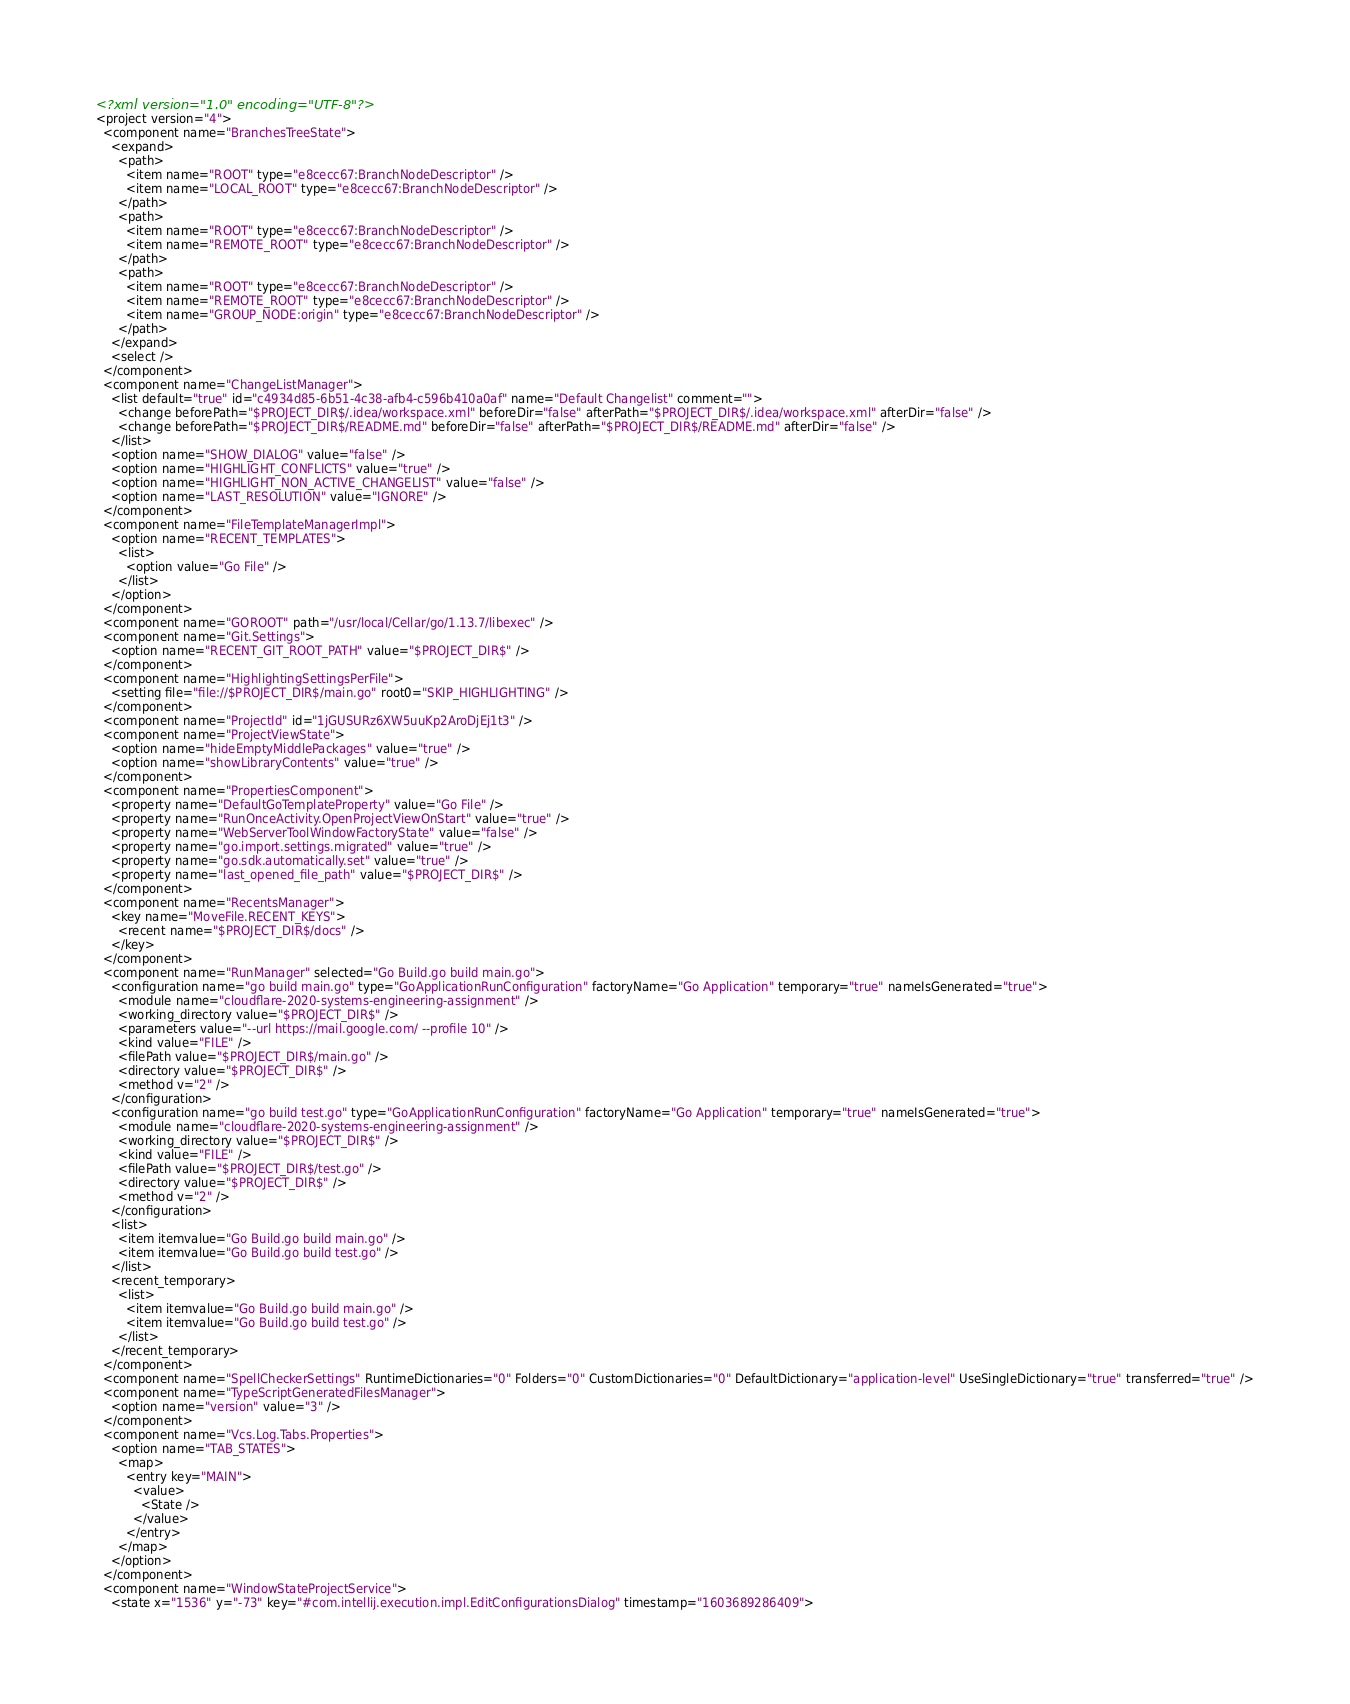Convert code to text. <code><loc_0><loc_0><loc_500><loc_500><_XML_><?xml version="1.0" encoding="UTF-8"?>
<project version="4">
  <component name="BranchesTreeState">
    <expand>
      <path>
        <item name="ROOT" type="e8cecc67:BranchNodeDescriptor" />
        <item name="LOCAL_ROOT" type="e8cecc67:BranchNodeDescriptor" />
      </path>
      <path>
        <item name="ROOT" type="e8cecc67:BranchNodeDescriptor" />
        <item name="REMOTE_ROOT" type="e8cecc67:BranchNodeDescriptor" />
      </path>
      <path>
        <item name="ROOT" type="e8cecc67:BranchNodeDescriptor" />
        <item name="REMOTE_ROOT" type="e8cecc67:BranchNodeDescriptor" />
        <item name="GROUP_NODE:origin" type="e8cecc67:BranchNodeDescriptor" />
      </path>
    </expand>
    <select />
  </component>
  <component name="ChangeListManager">
    <list default="true" id="c4934d85-6b51-4c38-afb4-c596b410a0af" name="Default Changelist" comment="">
      <change beforePath="$PROJECT_DIR$/.idea/workspace.xml" beforeDir="false" afterPath="$PROJECT_DIR$/.idea/workspace.xml" afterDir="false" />
      <change beforePath="$PROJECT_DIR$/README.md" beforeDir="false" afterPath="$PROJECT_DIR$/README.md" afterDir="false" />
    </list>
    <option name="SHOW_DIALOG" value="false" />
    <option name="HIGHLIGHT_CONFLICTS" value="true" />
    <option name="HIGHLIGHT_NON_ACTIVE_CHANGELIST" value="false" />
    <option name="LAST_RESOLUTION" value="IGNORE" />
  </component>
  <component name="FileTemplateManagerImpl">
    <option name="RECENT_TEMPLATES">
      <list>
        <option value="Go File" />
      </list>
    </option>
  </component>
  <component name="GOROOT" path="/usr/local/Cellar/go/1.13.7/libexec" />
  <component name="Git.Settings">
    <option name="RECENT_GIT_ROOT_PATH" value="$PROJECT_DIR$" />
  </component>
  <component name="HighlightingSettingsPerFile">
    <setting file="file://$PROJECT_DIR$/main.go" root0="SKIP_HIGHLIGHTING" />
  </component>
  <component name="ProjectId" id="1jGUSURz6XW5uuKp2AroDjEj1t3" />
  <component name="ProjectViewState">
    <option name="hideEmptyMiddlePackages" value="true" />
    <option name="showLibraryContents" value="true" />
  </component>
  <component name="PropertiesComponent">
    <property name="DefaultGoTemplateProperty" value="Go File" />
    <property name="RunOnceActivity.OpenProjectViewOnStart" value="true" />
    <property name="WebServerToolWindowFactoryState" value="false" />
    <property name="go.import.settings.migrated" value="true" />
    <property name="go.sdk.automatically.set" value="true" />
    <property name="last_opened_file_path" value="$PROJECT_DIR$" />
  </component>
  <component name="RecentsManager">
    <key name="MoveFile.RECENT_KEYS">
      <recent name="$PROJECT_DIR$/docs" />
    </key>
  </component>
  <component name="RunManager" selected="Go Build.go build main.go">
    <configuration name="go build main.go" type="GoApplicationRunConfiguration" factoryName="Go Application" temporary="true" nameIsGenerated="true">
      <module name="cloudflare-2020-systems-engineering-assignment" />
      <working_directory value="$PROJECT_DIR$" />
      <parameters value="--url https://mail.google.com/ --profile 10" />
      <kind value="FILE" />
      <filePath value="$PROJECT_DIR$/main.go" />
      <directory value="$PROJECT_DIR$" />
      <method v="2" />
    </configuration>
    <configuration name="go build test.go" type="GoApplicationRunConfiguration" factoryName="Go Application" temporary="true" nameIsGenerated="true">
      <module name="cloudflare-2020-systems-engineering-assignment" />
      <working_directory value="$PROJECT_DIR$" />
      <kind value="FILE" />
      <filePath value="$PROJECT_DIR$/test.go" />
      <directory value="$PROJECT_DIR$" />
      <method v="2" />
    </configuration>
    <list>
      <item itemvalue="Go Build.go build main.go" />
      <item itemvalue="Go Build.go build test.go" />
    </list>
    <recent_temporary>
      <list>
        <item itemvalue="Go Build.go build main.go" />
        <item itemvalue="Go Build.go build test.go" />
      </list>
    </recent_temporary>
  </component>
  <component name="SpellCheckerSettings" RuntimeDictionaries="0" Folders="0" CustomDictionaries="0" DefaultDictionary="application-level" UseSingleDictionary="true" transferred="true" />
  <component name="TypeScriptGeneratedFilesManager">
    <option name="version" value="3" />
  </component>
  <component name="Vcs.Log.Tabs.Properties">
    <option name="TAB_STATES">
      <map>
        <entry key="MAIN">
          <value>
            <State />
          </value>
        </entry>
      </map>
    </option>
  </component>
  <component name="WindowStateProjectService">
    <state x="1536" y="-73" key="#com.intellij.execution.impl.EditConfigurationsDialog" timestamp="1603689286409"></code> 